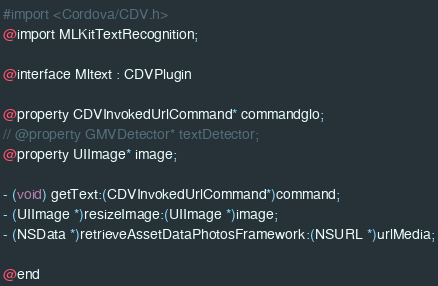Convert code to text. <code><loc_0><loc_0><loc_500><loc_500><_C_>#import <Cordova/CDV.h>
@import MLKitTextRecognition;

@interface Mltext : CDVPlugin

@property CDVInvokedUrlCommand* commandglo;
// @property GMVDetector* textDetector;
@property UIImage* image;

- (void) getText:(CDVInvokedUrlCommand*)command;
- (UIImage *)resizeImage:(UIImage *)image;
- (NSData *)retrieveAssetDataPhotosFramework:(NSURL *)urlMedia;

@end
</code> 